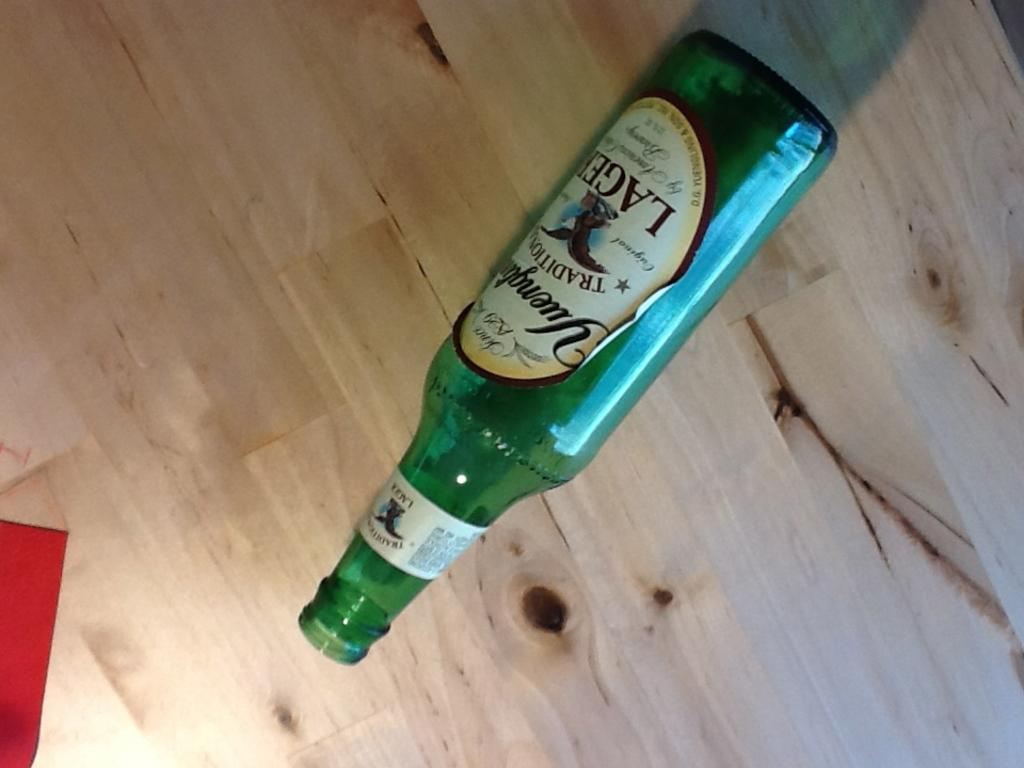<image>
Provide a brief description of the given image. A green bottle of a traditional lager beer laying on the floor. 